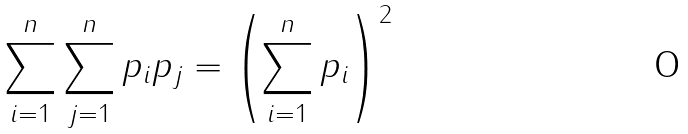<formula> <loc_0><loc_0><loc_500><loc_500>\sum _ { i = 1 } ^ { n } \sum _ { j = 1 } ^ { n } p _ { i } p _ { j } = \left ( \sum _ { i = 1 } ^ { n } p _ { i } \right ) ^ { 2 }</formula> 